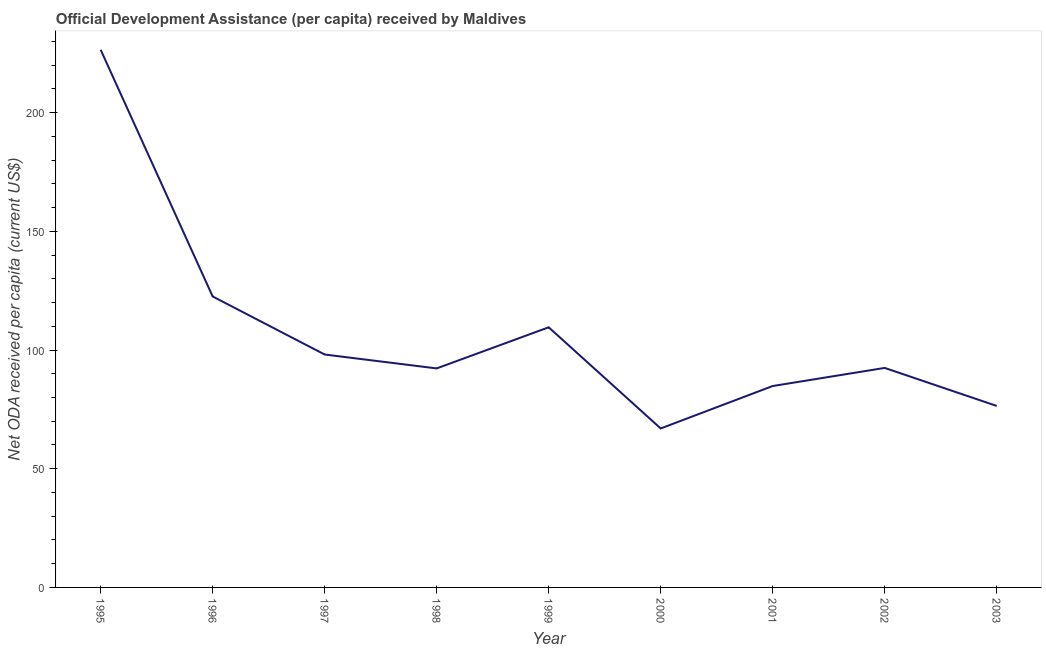What is the net oda received per capita in 2003?
Make the answer very short. 76.45. Across all years, what is the maximum net oda received per capita?
Ensure brevity in your answer.  226.47. Across all years, what is the minimum net oda received per capita?
Your response must be concise. 66.96. In which year was the net oda received per capita maximum?
Give a very brief answer. 1995. What is the sum of the net oda received per capita?
Offer a terse response. 969.65. What is the difference between the net oda received per capita in 1997 and 2002?
Provide a short and direct response. 5.65. What is the average net oda received per capita per year?
Your answer should be very brief. 107.74. What is the median net oda received per capita?
Ensure brevity in your answer.  92.46. What is the ratio of the net oda received per capita in 1998 to that in 2002?
Your answer should be very brief. 1. Is the difference between the net oda received per capita in 1996 and 1997 greater than the difference between any two years?
Offer a terse response. No. What is the difference between the highest and the second highest net oda received per capita?
Give a very brief answer. 103.91. Is the sum of the net oda received per capita in 1997 and 2002 greater than the maximum net oda received per capita across all years?
Offer a terse response. No. What is the difference between the highest and the lowest net oda received per capita?
Give a very brief answer. 159.51. In how many years, is the net oda received per capita greater than the average net oda received per capita taken over all years?
Your response must be concise. 3. How many lines are there?
Make the answer very short. 1. Are the values on the major ticks of Y-axis written in scientific E-notation?
Make the answer very short. No. Does the graph contain any zero values?
Your answer should be compact. No. Does the graph contain grids?
Provide a short and direct response. No. What is the title of the graph?
Your answer should be compact. Official Development Assistance (per capita) received by Maldives. What is the label or title of the Y-axis?
Offer a terse response. Net ODA received per capita (current US$). What is the Net ODA received per capita (current US$) in 1995?
Offer a very short reply. 226.47. What is the Net ODA received per capita (current US$) in 1996?
Keep it short and to the point. 122.56. What is the Net ODA received per capita (current US$) of 1997?
Keep it short and to the point. 98.11. What is the Net ODA received per capita (current US$) of 1998?
Give a very brief answer. 92.25. What is the Net ODA received per capita (current US$) of 1999?
Give a very brief answer. 109.57. What is the Net ODA received per capita (current US$) in 2000?
Make the answer very short. 66.96. What is the Net ODA received per capita (current US$) in 2001?
Your answer should be very brief. 84.83. What is the Net ODA received per capita (current US$) in 2002?
Keep it short and to the point. 92.46. What is the Net ODA received per capita (current US$) of 2003?
Your answer should be very brief. 76.45. What is the difference between the Net ODA received per capita (current US$) in 1995 and 1996?
Your response must be concise. 103.91. What is the difference between the Net ODA received per capita (current US$) in 1995 and 1997?
Offer a very short reply. 128.36. What is the difference between the Net ODA received per capita (current US$) in 1995 and 1998?
Make the answer very short. 134.22. What is the difference between the Net ODA received per capita (current US$) in 1995 and 1999?
Your response must be concise. 116.9. What is the difference between the Net ODA received per capita (current US$) in 1995 and 2000?
Your answer should be very brief. 159.51. What is the difference between the Net ODA received per capita (current US$) in 1995 and 2001?
Offer a very short reply. 141.64. What is the difference between the Net ODA received per capita (current US$) in 1995 and 2002?
Offer a terse response. 134.01. What is the difference between the Net ODA received per capita (current US$) in 1995 and 2003?
Your response must be concise. 150.02. What is the difference between the Net ODA received per capita (current US$) in 1996 and 1997?
Provide a succinct answer. 24.45. What is the difference between the Net ODA received per capita (current US$) in 1996 and 1998?
Keep it short and to the point. 30.31. What is the difference between the Net ODA received per capita (current US$) in 1996 and 1999?
Make the answer very short. 12.99. What is the difference between the Net ODA received per capita (current US$) in 1996 and 2000?
Your response must be concise. 55.6. What is the difference between the Net ODA received per capita (current US$) in 1996 and 2001?
Offer a very short reply. 37.73. What is the difference between the Net ODA received per capita (current US$) in 1996 and 2002?
Offer a terse response. 30.1. What is the difference between the Net ODA received per capita (current US$) in 1996 and 2003?
Your answer should be compact. 46.11. What is the difference between the Net ODA received per capita (current US$) in 1997 and 1998?
Your answer should be compact. 5.86. What is the difference between the Net ODA received per capita (current US$) in 1997 and 1999?
Your answer should be very brief. -11.47. What is the difference between the Net ODA received per capita (current US$) in 1997 and 2000?
Keep it short and to the point. 31.15. What is the difference between the Net ODA received per capita (current US$) in 1997 and 2001?
Offer a terse response. 13.28. What is the difference between the Net ODA received per capita (current US$) in 1997 and 2002?
Your answer should be very brief. 5.65. What is the difference between the Net ODA received per capita (current US$) in 1997 and 2003?
Your answer should be very brief. 21.66. What is the difference between the Net ODA received per capita (current US$) in 1998 and 1999?
Ensure brevity in your answer.  -17.32. What is the difference between the Net ODA received per capita (current US$) in 1998 and 2000?
Provide a succinct answer. 25.29. What is the difference between the Net ODA received per capita (current US$) in 1998 and 2001?
Your answer should be compact. 7.42. What is the difference between the Net ODA received per capita (current US$) in 1998 and 2002?
Offer a very short reply. -0.21. What is the difference between the Net ODA received per capita (current US$) in 1998 and 2003?
Offer a very short reply. 15.8. What is the difference between the Net ODA received per capita (current US$) in 1999 and 2000?
Your answer should be very brief. 42.61. What is the difference between the Net ODA received per capita (current US$) in 1999 and 2001?
Make the answer very short. 24.74. What is the difference between the Net ODA received per capita (current US$) in 1999 and 2002?
Make the answer very short. 17.11. What is the difference between the Net ODA received per capita (current US$) in 1999 and 2003?
Keep it short and to the point. 33.12. What is the difference between the Net ODA received per capita (current US$) in 2000 and 2001?
Offer a very short reply. -17.87. What is the difference between the Net ODA received per capita (current US$) in 2000 and 2002?
Provide a succinct answer. -25.5. What is the difference between the Net ODA received per capita (current US$) in 2000 and 2003?
Offer a terse response. -9.49. What is the difference between the Net ODA received per capita (current US$) in 2001 and 2002?
Provide a succinct answer. -7.63. What is the difference between the Net ODA received per capita (current US$) in 2001 and 2003?
Your response must be concise. 8.38. What is the difference between the Net ODA received per capita (current US$) in 2002 and 2003?
Ensure brevity in your answer.  16.01. What is the ratio of the Net ODA received per capita (current US$) in 1995 to that in 1996?
Offer a very short reply. 1.85. What is the ratio of the Net ODA received per capita (current US$) in 1995 to that in 1997?
Your response must be concise. 2.31. What is the ratio of the Net ODA received per capita (current US$) in 1995 to that in 1998?
Make the answer very short. 2.46. What is the ratio of the Net ODA received per capita (current US$) in 1995 to that in 1999?
Ensure brevity in your answer.  2.07. What is the ratio of the Net ODA received per capita (current US$) in 1995 to that in 2000?
Give a very brief answer. 3.38. What is the ratio of the Net ODA received per capita (current US$) in 1995 to that in 2001?
Ensure brevity in your answer.  2.67. What is the ratio of the Net ODA received per capita (current US$) in 1995 to that in 2002?
Offer a very short reply. 2.45. What is the ratio of the Net ODA received per capita (current US$) in 1995 to that in 2003?
Your response must be concise. 2.96. What is the ratio of the Net ODA received per capita (current US$) in 1996 to that in 1997?
Your answer should be very brief. 1.25. What is the ratio of the Net ODA received per capita (current US$) in 1996 to that in 1998?
Your answer should be very brief. 1.33. What is the ratio of the Net ODA received per capita (current US$) in 1996 to that in 1999?
Offer a terse response. 1.12. What is the ratio of the Net ODA received per capita (current US$) in 1996 to that in 2000?
Your answer should be compact. 1.83. What is the ratio of the Net ODA received per capita (current US$) in 1996 to that in 2001?
Provide a short and direct response. 1.45. What is the ratio of the Net ODA received per capita (current US$) in 1996 to that in 2002?
Your response must be concise. 1.33. What is the ratio of the Net ODA received per capita (current US$) in 1996 to that in 2003?
Offer a terse response. 1.6. What is the ratio of the Net ODA received per capita (current US$) in 1997 to that in 1998?
Your response must be concise. 1.06. What is the ratio of the Net ODA received per capita (current US$) in 1997 to that in 1999?
Provide a succinct answer. 0.9. What is the ratio of the Net ODA received per capita (current US$) in 1997 to that in 2000?
Keep it short and to the point. 1.47. What is the ratio of the Net ODA received per capita (current US$) in 1997 to that in 2001?
Your response must be concise. 1.16. What is the ratio of the Net ODA received per capita (current US$) in 1997 to that in 2002?
Make the answer very short. 1.06. What is the ratio of the Net ODA received per capita (current US$) in 1997 to that in 2003?
Your answer should be compact. 1.28. What is the ratio of the Net ODA received per capita (current US$) in 1998 to that in 1999?
Ensure brevity in your answer.  0.84. What is the ratio of the Net ODA received per capita (current US$) in 1998 to that in 2000?
Give a very brief answer. 1.38. What is the ratio of the Net ODA received per capita (current US$) in 1998 to that in 2001?
Offer a very short reply. 1.09. What is the ratio of the Net ODA received per capita (current US$) in 1998 to that in 2003?
Keep it short and to the point. 1.21. What is the ratio of the Net ODA received per capita (current US$) in 1999 to that in 2000?
Your response must be concise. 1.64. What is the ratio of the Net ODA received per capita (current US$) in 1999 to that in 2001?
Give a very brief answer. 1.29. What is the ratio of the Net ODA received per capita (current US$) in 1999 to that in 2002?
Provide a succinct answer. 1.19. What is the ratio of the Net ODA received per capita (current US$) in 1999 to that in 2003?
Make the answer very short. 1.43. What is the ratio of the Net ODA received per capita (current US$) in 2000 to that in 2001?
Keep it short and to the point. 0.79. What is the ratio of the Net ODA received per capita (current US$) in 2000 to that in 2002?
Provide a short and direct response. 0.72. What is the ratio of the Net ODA received per capita (current US$) in 2000 to that in 2003?
Make the answer very short. 0.88. What is the ratio of the Net ODA received per capita (current US$) in 2001 to that in 2002?
Provide a succinct answer. 0.92. What is the ratio of the Net ODA received per capita (current US$) in 2001 to that in 2003?
Ensure brevity in your answer.  1.11. What is the ratio of the Net ODA received per capita (current US$) in 2002 to that in 2003?
Offer a terse response. 1.21. 